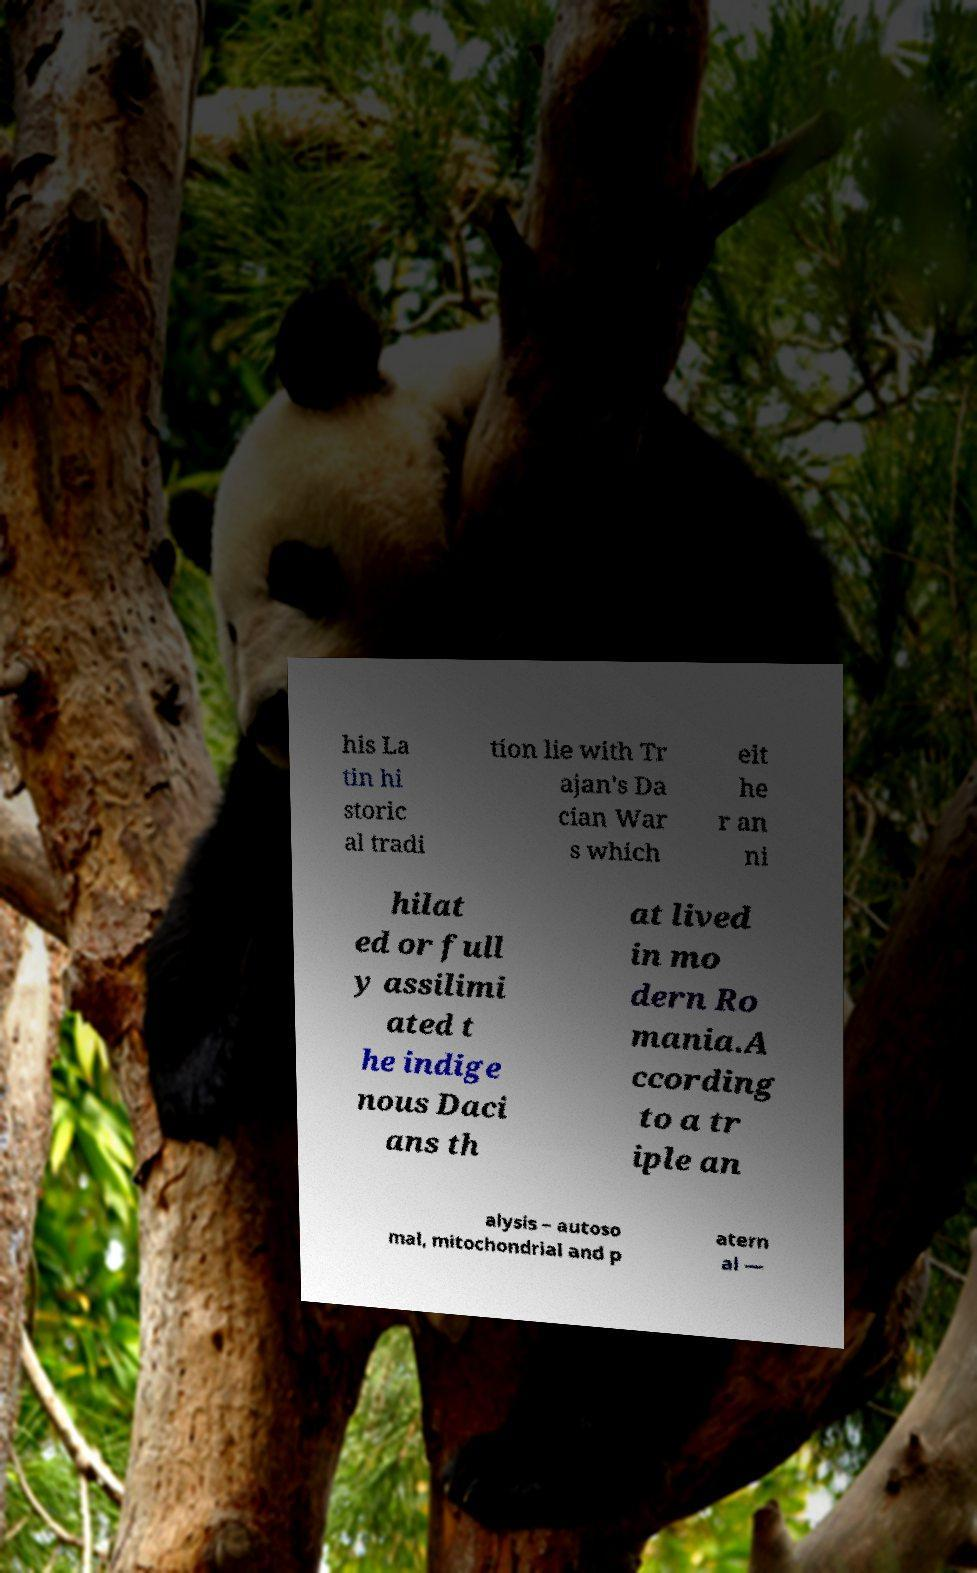I need the written content from this picture converted into text. Can you do that? his La tin hi storic al tradi tion lie with Tr ajan's Da cian War s which eit he r an ni hilat ed or full y assilimi ated t he indige nous Daci ans th at lived in mo dern Ro mania.A ccording to a tr iple an alysis – autoso mal, mitochondrial and p atern al — 